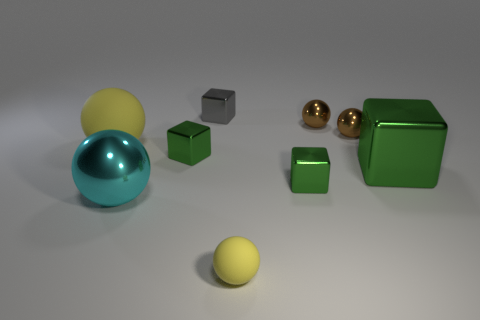Do the ball that is on the left side of the big cyan sphere and the big shiny ball have the same color?
Your answer should be compact. No. Do the cyan sphere and the gray metallic thing have the same size?
Offer a very short reply. No. What is the shape of the yellow object that is the same size as the gray object?
Ensure brevity in your answer.  Sphere. There is a thing that is to the left of the cyan metal ball; does it have the same size as the small gray shiny block?
Provide a short and direct response. No. There is a yellow thing that is the same size as the cyan object; what is it made of?
Your answer should be compact. Rubber. There is a green metal block to the left of the small yellow thing that is to the right of the small gray shiny object; are there any balls that are to the left of it?
Your answer should be very brief. Yes. Is there any other thing that has the same shape as the big cyan object?
Keep it short and to the point. Yes. There is a block on the left side of the gray block; is its color the same as the matte ball that is behind the tiny yellow object?
Ensure brevity in your answer.  No. Are any small brown rubber cylinders visible?
Provide a short and direct response. No. There is a thing that is the same color as the small rubber sphere; what material is it?
Offer a very short reply. Rubber. 